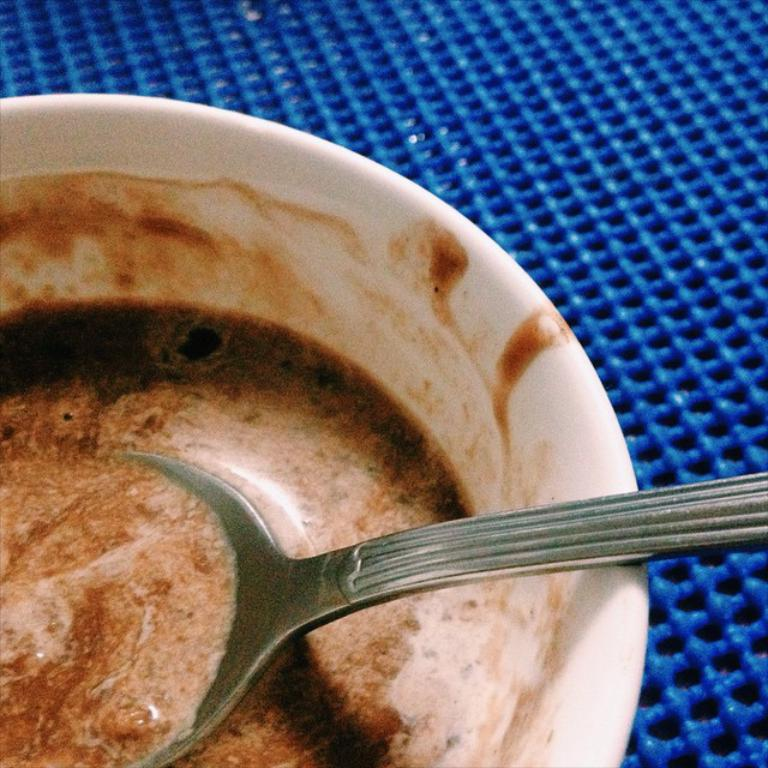What type of food can be seen in the image? There is food in the image, but the specific type is not mentioned in the facts. What utensil is present in the image? There is a spoon in the image. In what type of container is the food placed? The food is in a white bowl. What is located at the bottom of the image? There is a table mat at the bottom of the image. How many tomatoes are on the table in the image? There is no mention of tomatoes in the image, so we cannot determine their presence or quantity. Is there a prison visible in the image? There is no prison present in the image. Can you see an owl in the image? There is no owl present in the image. 